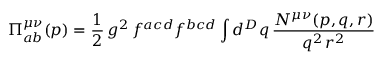Convert formula to latex. <formula><loc_0><loc_0><loc_500><loc_500>\Pi _ { a b } ^ { \mu \nu } ( p ) = \frac { 1 } { 2 } \, g ^ { 2 } \, f ^ { a c d } f ^ { b c d } \int d ^ { D } q \, \frac { N ^ { \mu \nu } ( p , q , r ) } { q ^ { 2 } \, r ^ { 2 } }</formula> 